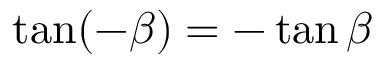Convert formula to latex. <formula><loc_0><loc_0><loc_500><loc_500>\tan ( - \beta ) = - \tan \beta</formula> 